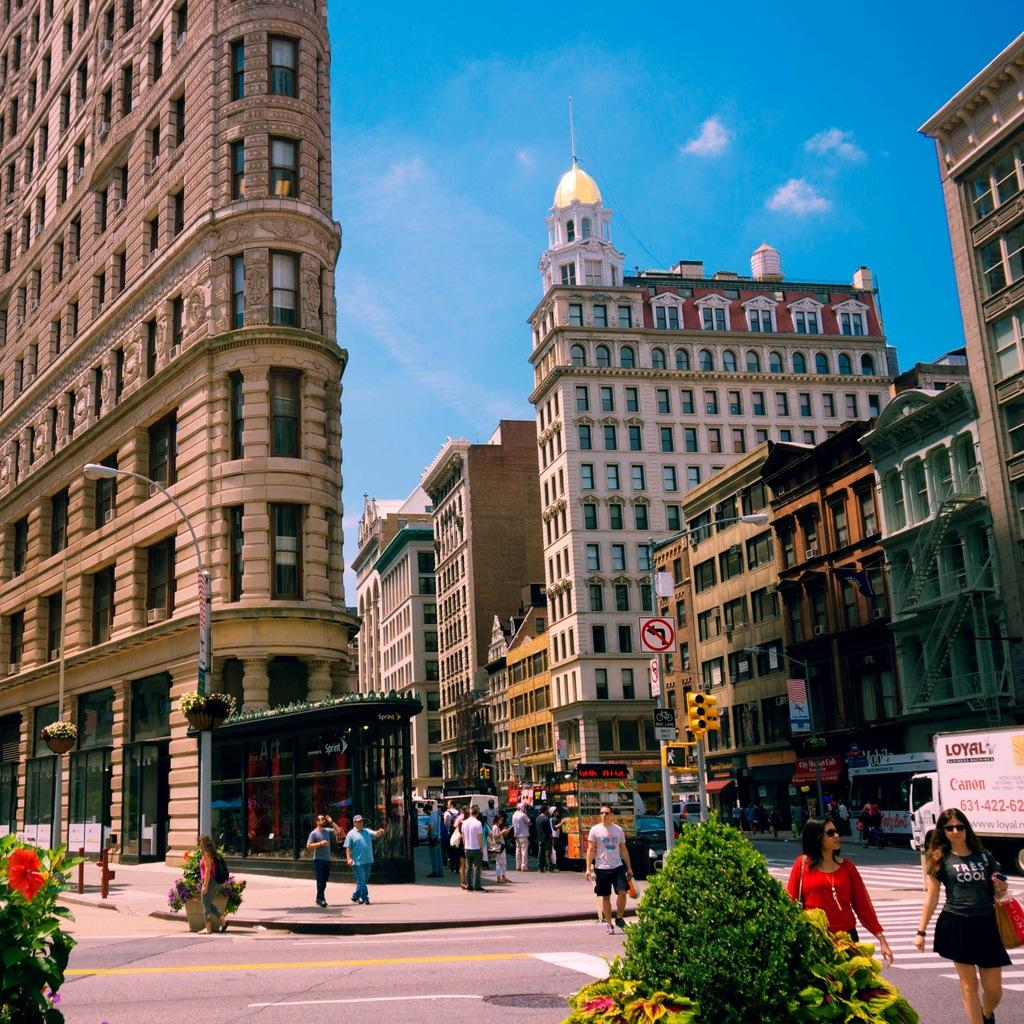What type of structures are visible in the image? There are buildings with windows in the image. What are the people in the image doing? People are walking on the road in the image. What type of vegetation is present in the image? There are trees in the image. What is visible in the background of the image? The sky is visible in the image. Where is the hen located in the image? There is no hen present in the image. What type of spark can be seen coming from the buildings in the image? There is no spark visible in the image; the buildings have windows, but no indication of a spark. 